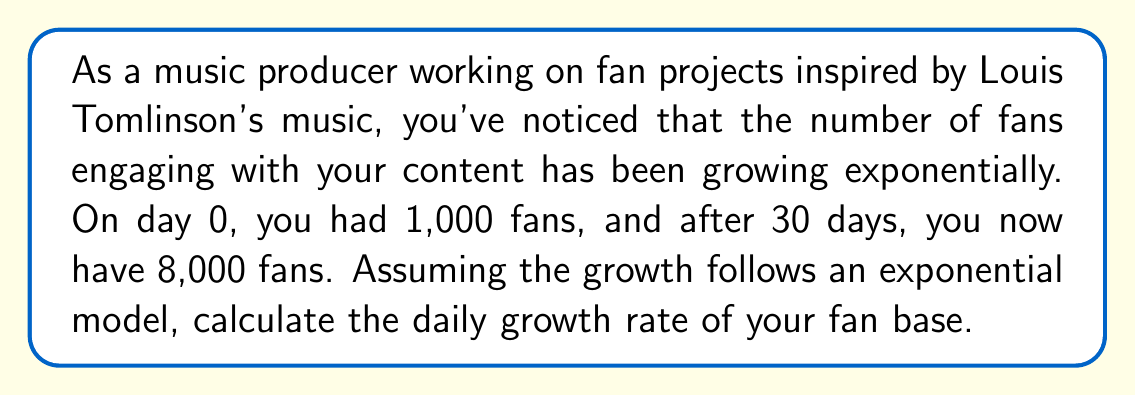Help me with this question. To solve this problem, we'll use the exponential growth model:

$$P(t) = P_0 \cdot e^{rt}$$

Where:
$P(t)$ is the population (number of fans) at time $t$
$P_0$ is the initial population
$r$ is the growth rate (per day)
$t$ is the time (in days)
$e$ is Euler's number (approximately 2.71828)

Given:
$P_0 = 1,000$ (initial number of fans)
$P(30) = 8,000$ (number of fans after 30 days)
$t = 30$ days

Let's substitute these values into the equation:

$$8,000 = 1,000 \cdot e^{r \cdot 30}$$

Now we need to solve for $r$:

1) Divide both sides by 1,000:
   $$8 = e^{30r}$$

2) Take the natural logarithm of both sides:
   $$\ln(8) = 30r$$

3) Solve for $r$:
   $$r = \frac{\ln(8)}{30}$$

4) Calculate the value:
   $$r = \frac{\ln(8)}{30} \approx 0.0693$$

To express this as a percentage, multiply by 100:

$$0.0693 \cdot 100 \approx 6.93\%$$
Answer: The daily growth rate of the fan base is approximately 6.93%. 